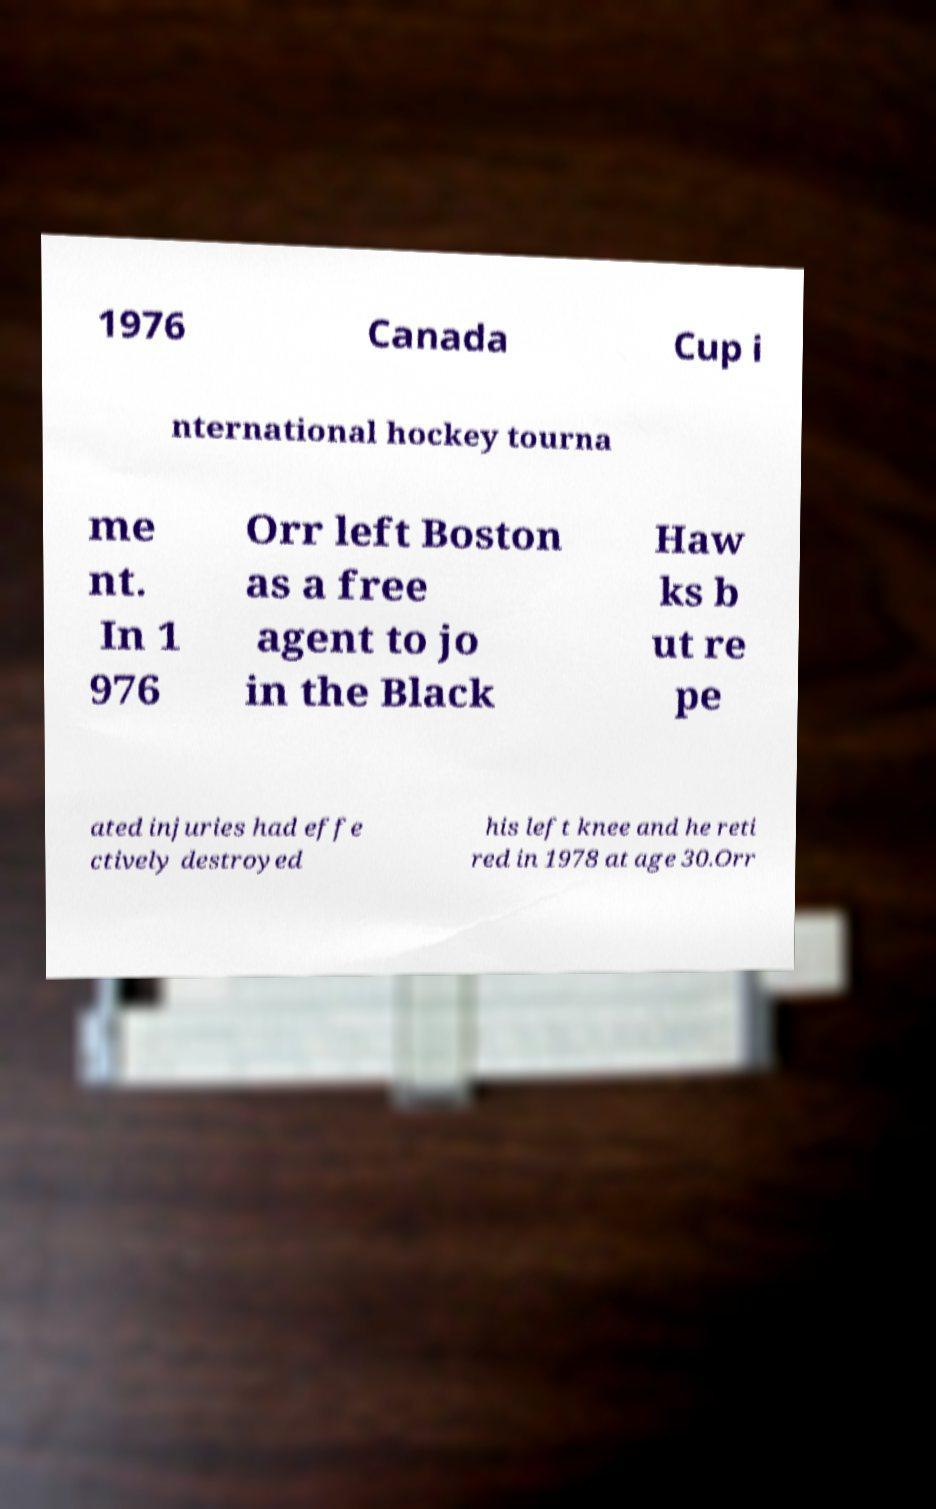What messages or text are displayed in this image? I need them in a readable, typed format. 1976 Canada Cup i nternational hockey tourna me nt. In 1 976 Orr left Boston as a free agent to jo in the Black Haw ks b ut re pe ated injuries had effe ctively destroyed his left knee and he reti red in 1978 at age 30.Orr 